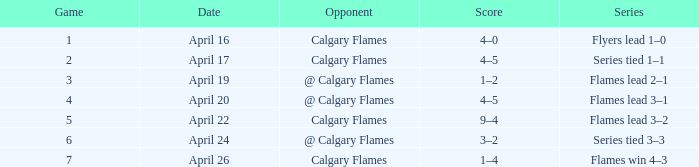On which date is there a game with less than 4, and an adversary as calgary flames, and a score of 4-5? April 17. 